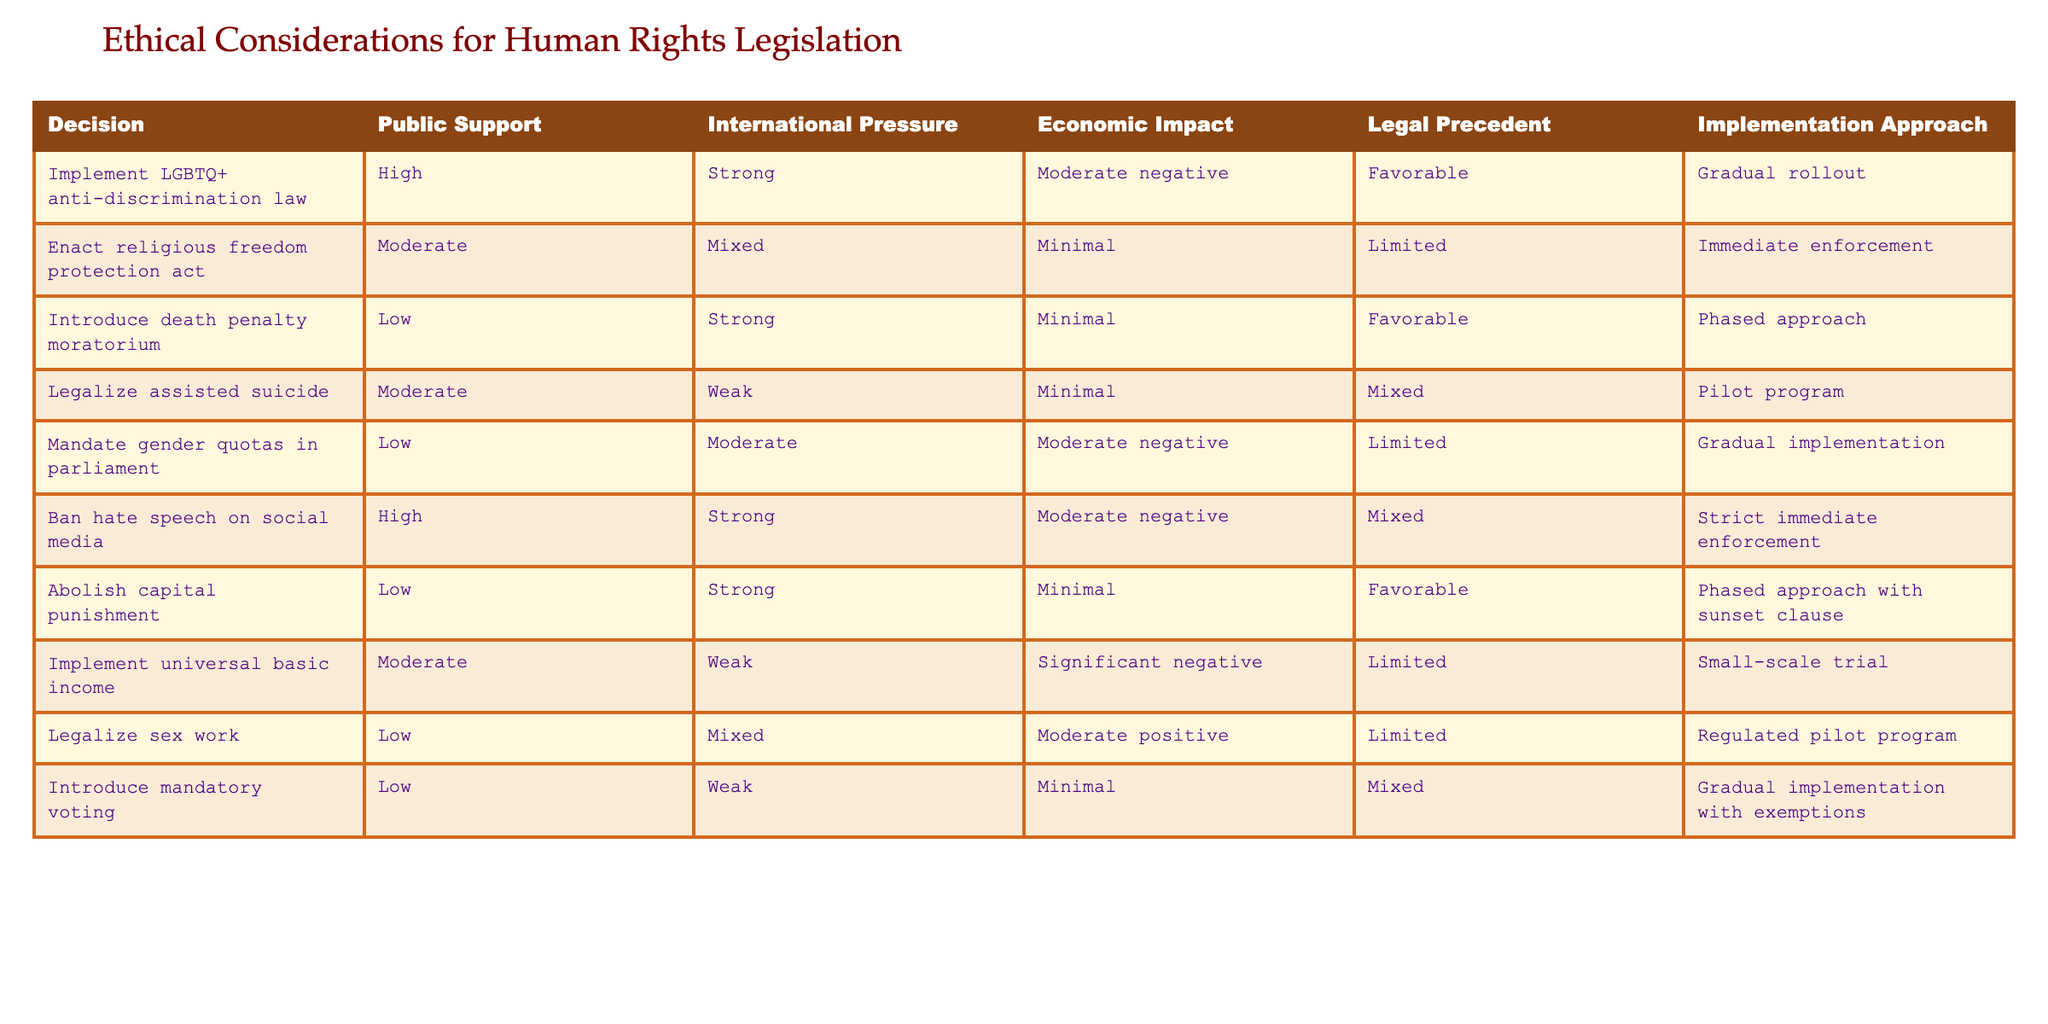What is the implementation approach for legalizing assisted suicide? The implementation approach for legalizing assisted suicide according to the table is a pilot program, which can be found in the last column of that specific row.
Answer: Pilot program How many laws have high public support? Looking at the table, there are two laws with high public support, specifically the LGBTQ+ anti-discrimination law and the ban on hate speech on social media.
Answer: 2 Does the introduction of the death penalty moratorium have strong international pressure? According to the table, the death penalty moratorium has strong international pressure, as indicated directly in the row concerning that legislation.
Answer: Yes What is the economic impact of implementing universal basic income? The economic impact listed in the table for implementing universal basic income is a significant negative, which can be confirmed by looking at the economic impact column in the respective row.
Answer: Significant negative Which legislation has a moderate legal precedent? The legislation that has a moderate legal precedent is the legalization of assisted suicide, as noted in the legal precedent column for that row.
Answer: Legalize assisted suicide How does the economic impact of gender quotas in parliament compare to banning hate speech on social media? For gender quotas in parliament, the economic impact is noted as moderate negative, while the economic impact for banning hate speech on social media is moderate negative as well. Since both are the same, we conclude they are equal.
Answer: They are equal Is there any legislation with mixed public support and weak international pressure? Examining the table, the only legislation that fits this criterion is the legalization of sex work, which is the only instance of mixed public support occurring alongside weak international pressure.
Answer: Yes What is the average level of public support for laws with immediate enforcement? There are three laws with immediate enforcement: the religious freedom protection act, the ban on hate speech, and the mandate for gender quotas. Their public support levels are moderate, high, and low, respectively. The average can be calculated as (moderate=50 + high=100 + low=25) / 3 = 58.33, which rounds to about 58 when considering rated values.
Answer: Approximately 58 What legal precedents are favorable among the listed legislation? The legal precedents categorized as favorable are seen in the rows for the introduction of the death penalty moratorium and the abolition of capital punishment. Both laws have "favorable" recorded in their respective legal precedent columns.
Answer: Death penalty moratorium, abolish capital punishment 